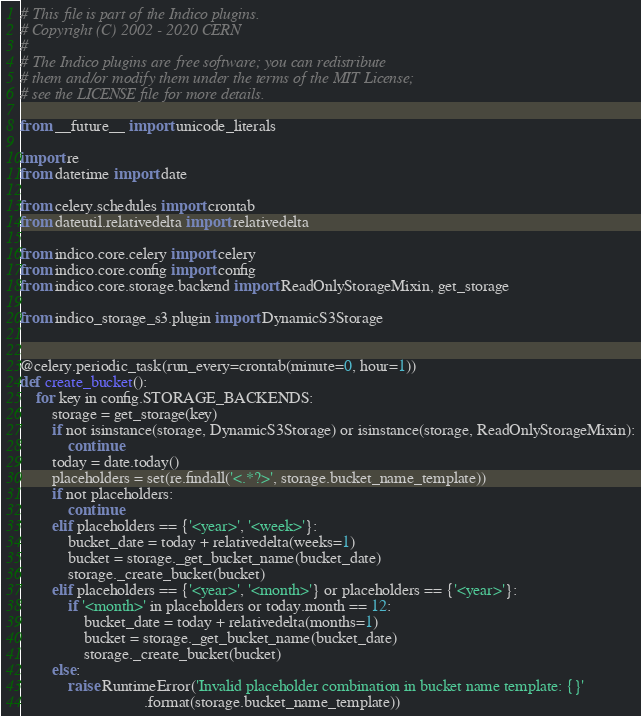Convert code to text. <code><loc_0><loc_0><loc_500><loc_500><_Python_># This file is part of the Indico plugins.
# Copyright (C) 2002 - 2020 CERN
#
# The Indico plugins are free software; you can redistribute
# them and/or modify them under the terms of the MIT License;
# see the LICENSE file for more details.

from __future__ import unicode_literals

import re
from datetime import date

from celery.schedules import crontab
from dateutil.relativedelta import relativedelta

from indico.core.celery import celery
from indico.core.config import config
from indico.core.storage.backend import ReadOnlyStorageMixin, get_storage

from indico_storage_s3.plugin import DynamicS3Storage


@celery.periodic_task(run_every=crontab(minute=0, hour=1))
def create_bucket():
    for key in config.STORAGE_BACKENDS:
        storage = get_storage(key)
        if not isinstance(storage, DynamicS3Storage) or isinstance(storage, ReadOnlyStorageMixin):
            continue
        today = date.today()
        placeholders = set(re.findall('<.*?>', storage.bucket_name_template))
        if not placeholders:
            continue
        elif placeholders == {'<year>', '<week>'}:
            bucket_date = today + relativedelta(weeks=1)
            bucket = storage._get_bucket_name(bucket_date)
            storage._create_bucket(bucket)
        elif placeholders == {'<year>', '<month>'} or placeholders == {'<year>'}:
            if '<month>' in placeholders or today.month == 12:
                bucket_date = today + relativedelta(months=1)
                bucket = storage._get_bucket_name(bucket_date)
                storage._create_bucket(bucket)
        else:
            raise RuntimeError('Invalid placeholder combination in bucket name template: {}'
                               .format(storage.bucket_name_template))
</code> 